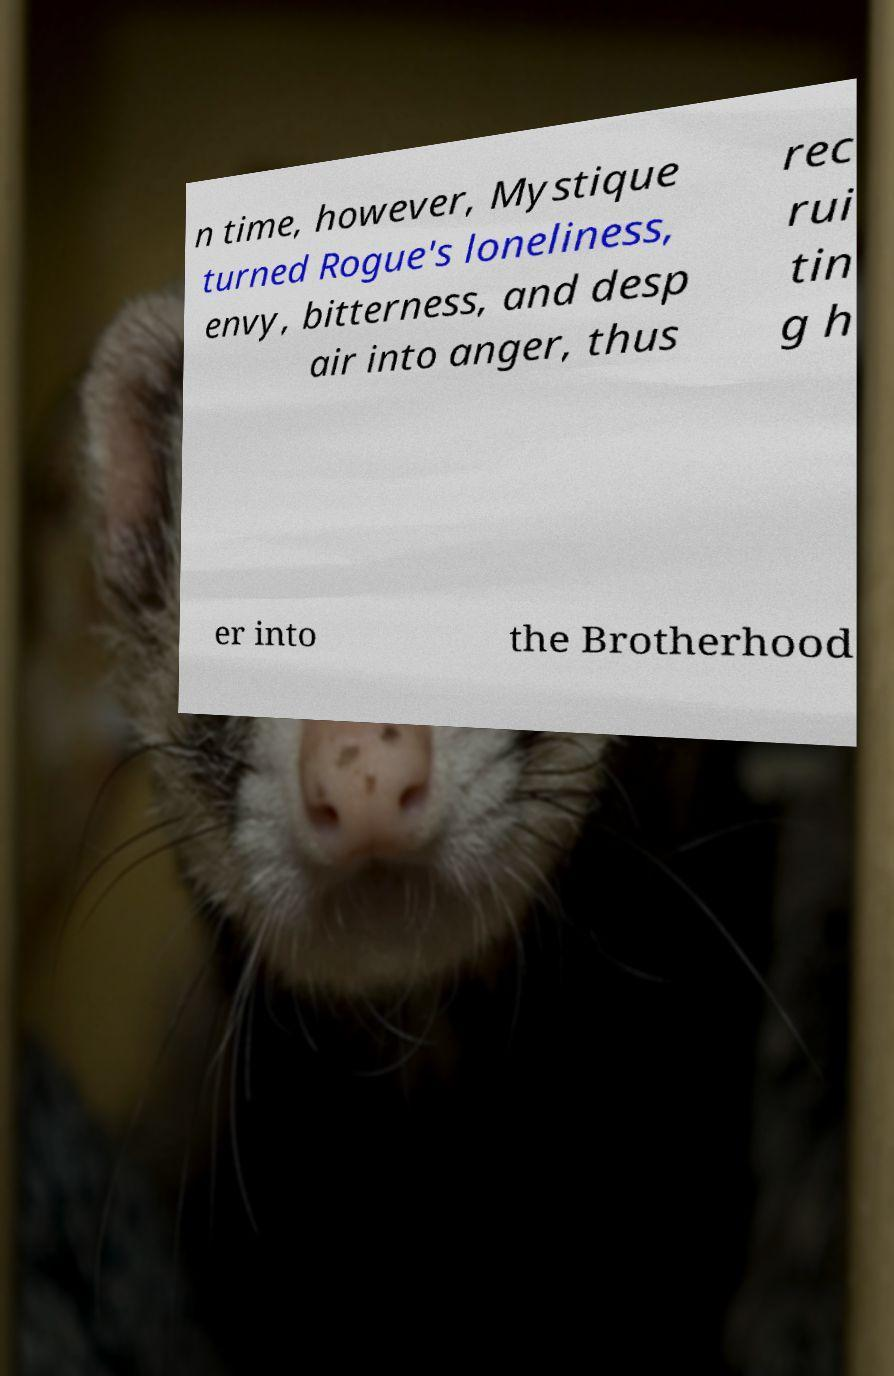Can you accurately transcribe the text from the provided image for me? n time, however, Mystique turned Rogue's loneliness, envy, bitterness, and desp air into anger, thus rec rui tin g h er into the Brotherhood 